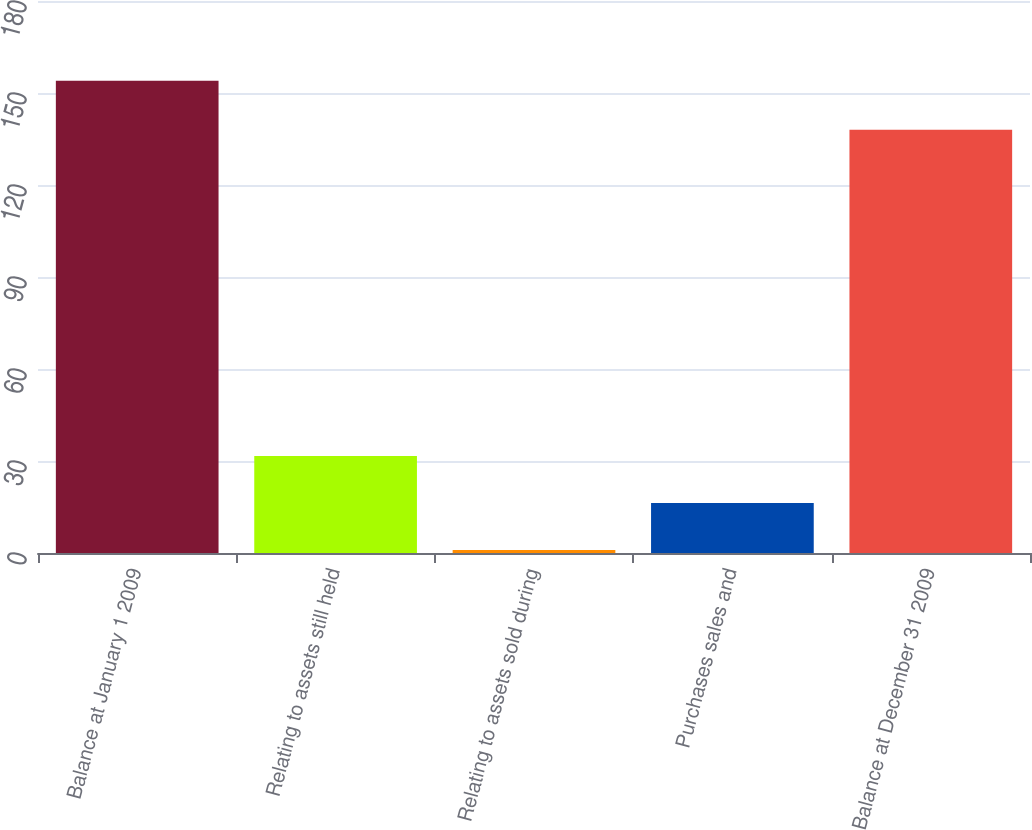Convert chart. <chart><loc_0><loc_0><loc_500><loc_500><bar_chart><fcel>Balance at January 1 2009<fcel>Relating to assets still held<fcel>Relating to assets sold during<fcel>Purchases sales and<fcel>Balance at December 31 2009<nl><fcel>154<fcel>31.6<fcel>1<fcel>16.3<fcel>138<nl></chart> 